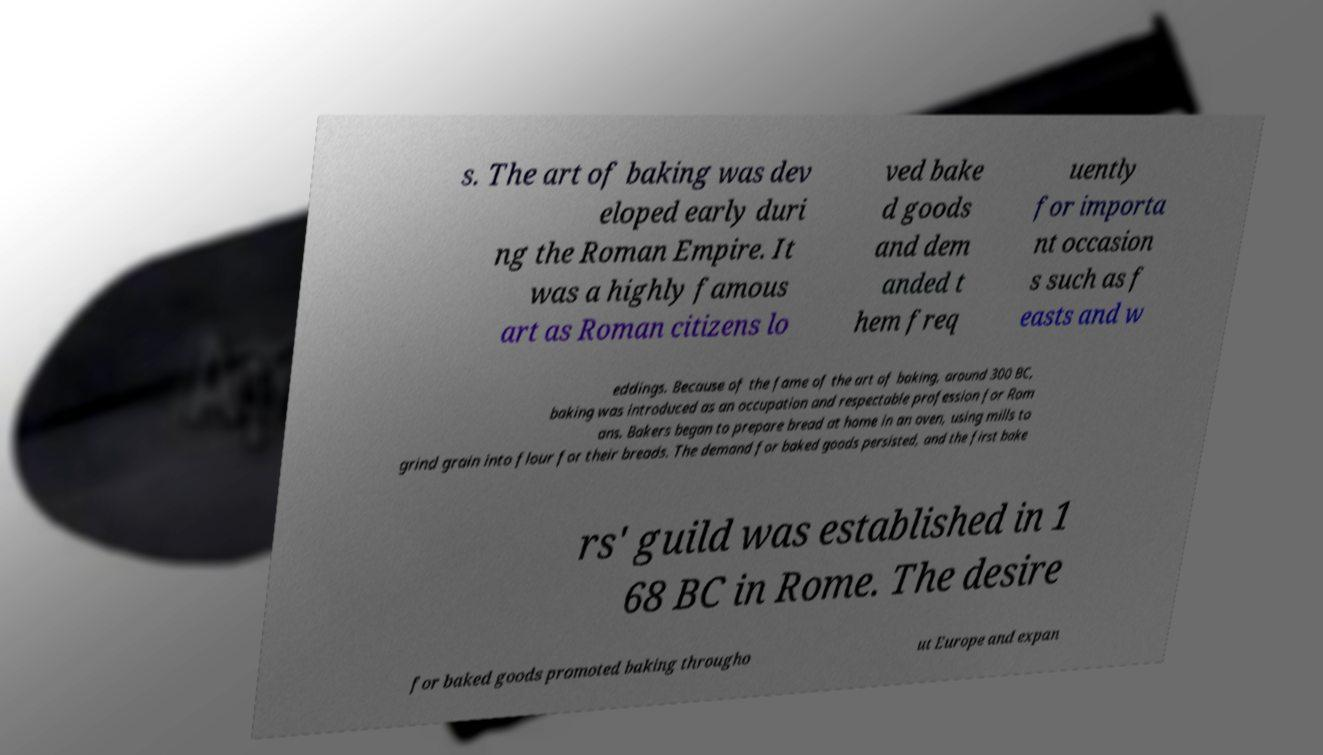Could you extract and type out the text from this image? s. The art of baking was dev eloped early duri ng the Roman Empire. It was a highly famous art as Roman citizens lo ved bake d goods and dem anded t hem freq uently for importa nt occasion s such as f easts and w eddings. Because of the fame of the art of baking, around 300 BC, baking was introduced as an occupation and respectable profession for Rom ans. Bakers began to prepare bread at home in an oven, using mills to grind grain into flour for their breads. The demand for baked goods persisted, and the first bake rs' guild was established in 1 68 BC in Rome. The desire for baked goods promoted baking througho ut Europe and expan 